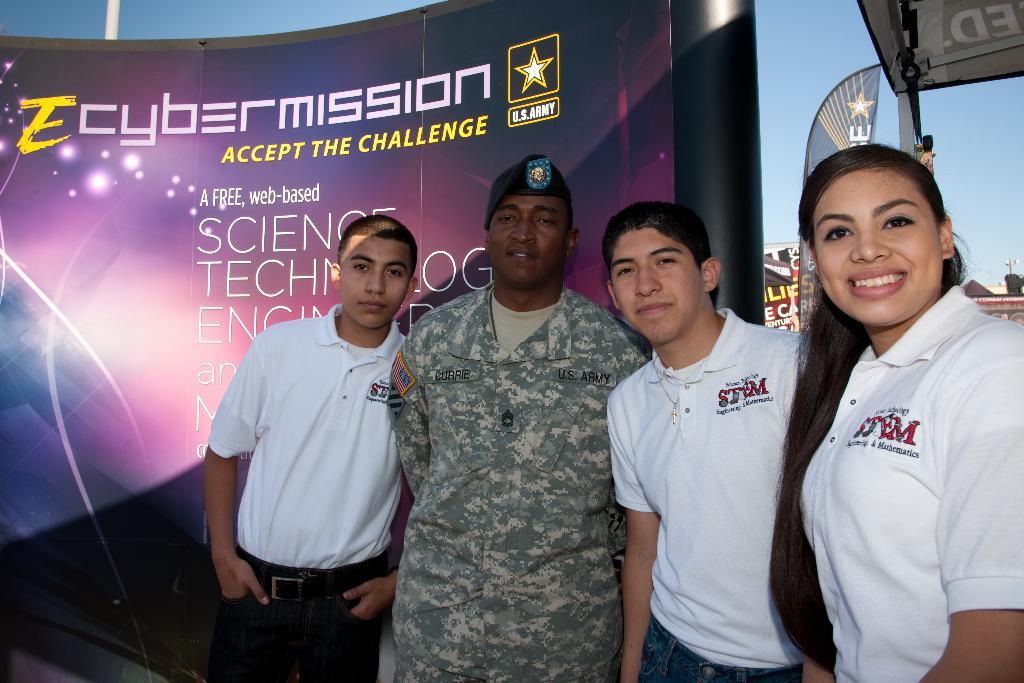How many people are in the image? There are four persons in the image. What are the dresses of three of the persons like? Three of the persons are wearing the same dress. What type of dress is the fourth person wearing? The fourth person is wearing a military dress. What can be seen in the background of the image? There is a banner in the image, and the sky is visible at the top of the image. How many houses are visible in the image? There are no houses visible in the image. What type of brass instrument is being played by the persons in the image? There is no brass instrument present in the image. 